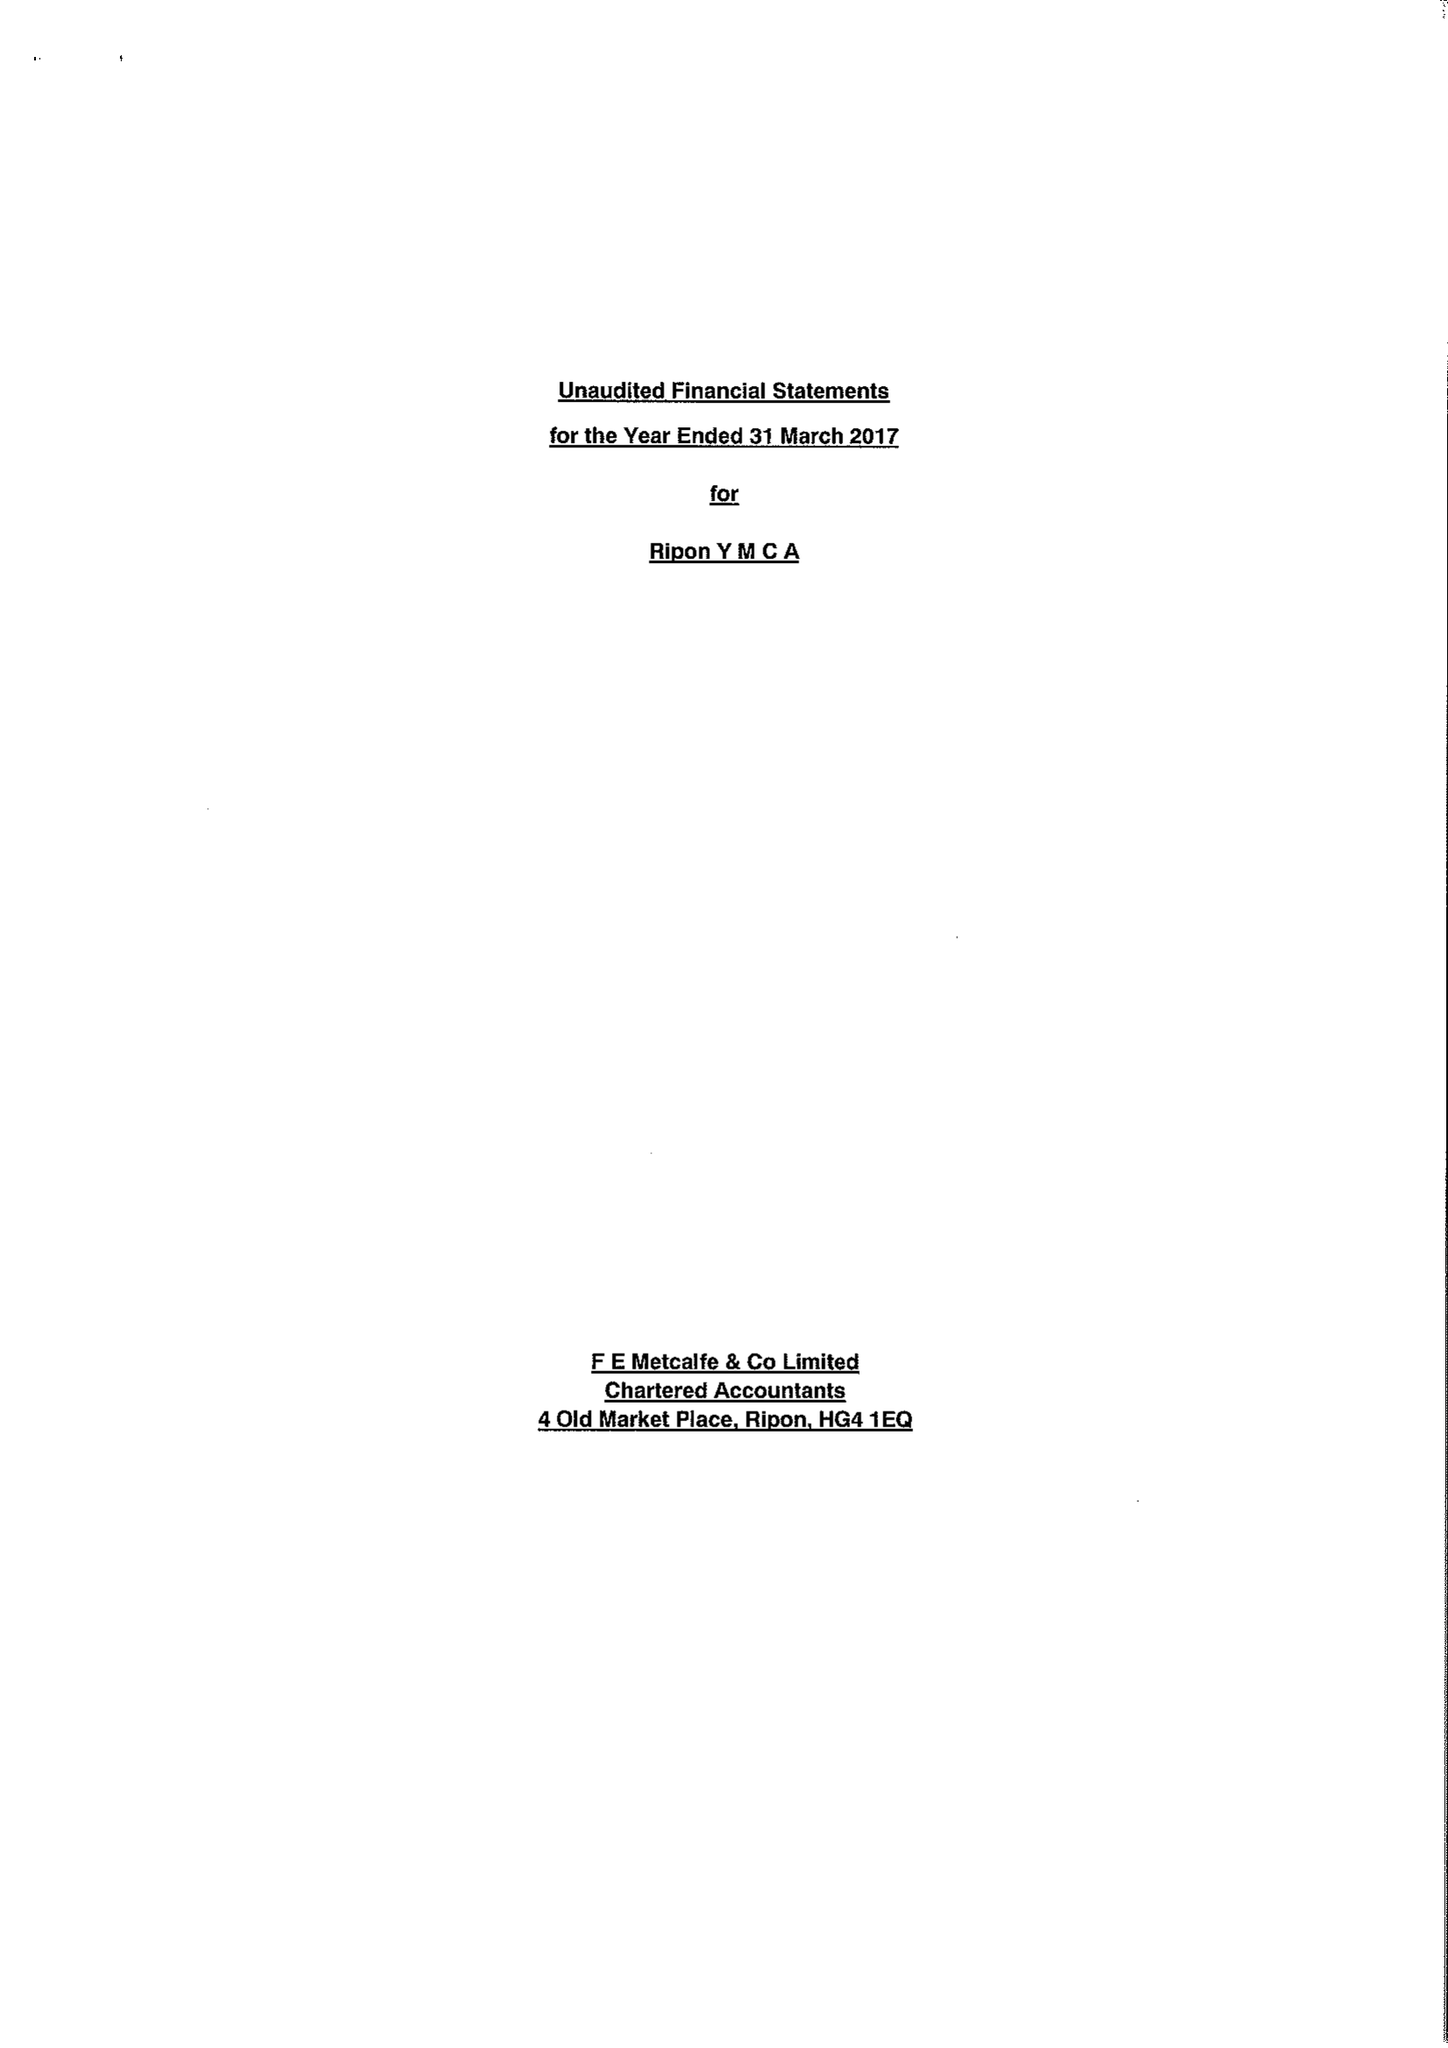What is the value for the address__post_town?
Answer the question using a single word or phrase. RIPON 